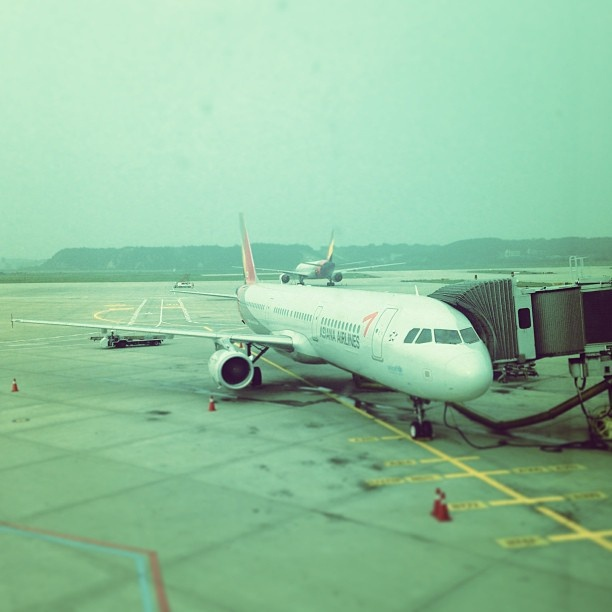Describe the objects in this image and their specific colors. I can see airplane in beige, aquamarine, and turquoise tones and airplane in beige, teal, and aquamarine tones in this image. 